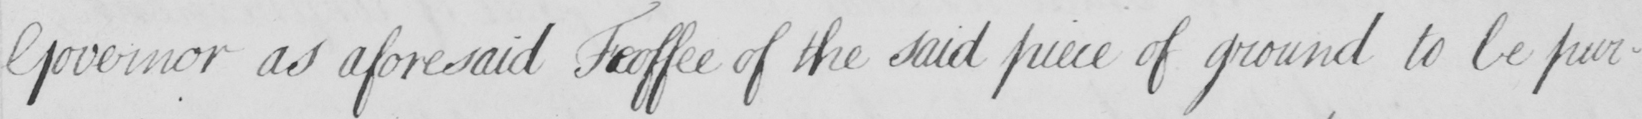What text is written in this handwritten line? Governor as aforesaid Feoffee of the said piece of ground to be pur- 